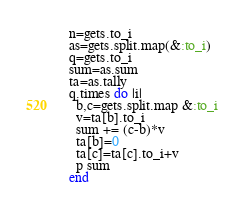Convert code to text. <code><loc_0><loc_0><loc_500><loc_500><_Ruby_>n=gets.to_i
as=gets.split.map(&:to_i)
q=gets.to_i
sum=as.sum
ta=as.tally
q.times do |i|
  b,c=gets.split.map &:to_i
  v=ta[b].to_i
  sum += (c-b)*v
  ta[b]=0
  ta[c]=ta[c].to_i+v
  p sum
end</code> 